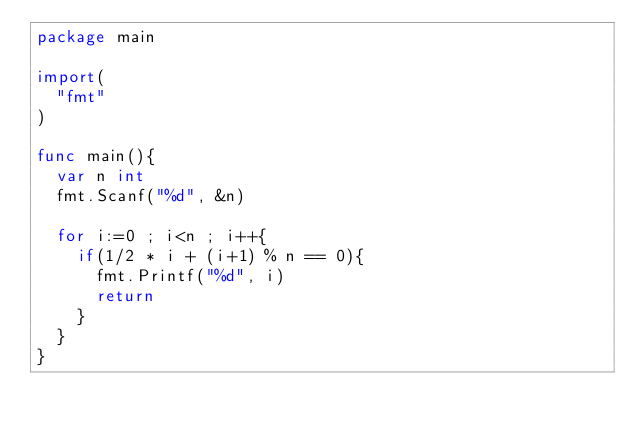Convert code to text. <code><loc_0><loc_0><loc_500><loc_500><_Go_>package main

import(
  "fmt"
)

func main(){
  var n int
  fmt.Scanf("%d", &n)
  
  for i:=0 ; i<n ; i++{
  	if(1/2 * i + (i+1) % n == 0){
      fmt.Printf("%d", i)
      return
  	}
  }
}</code> 